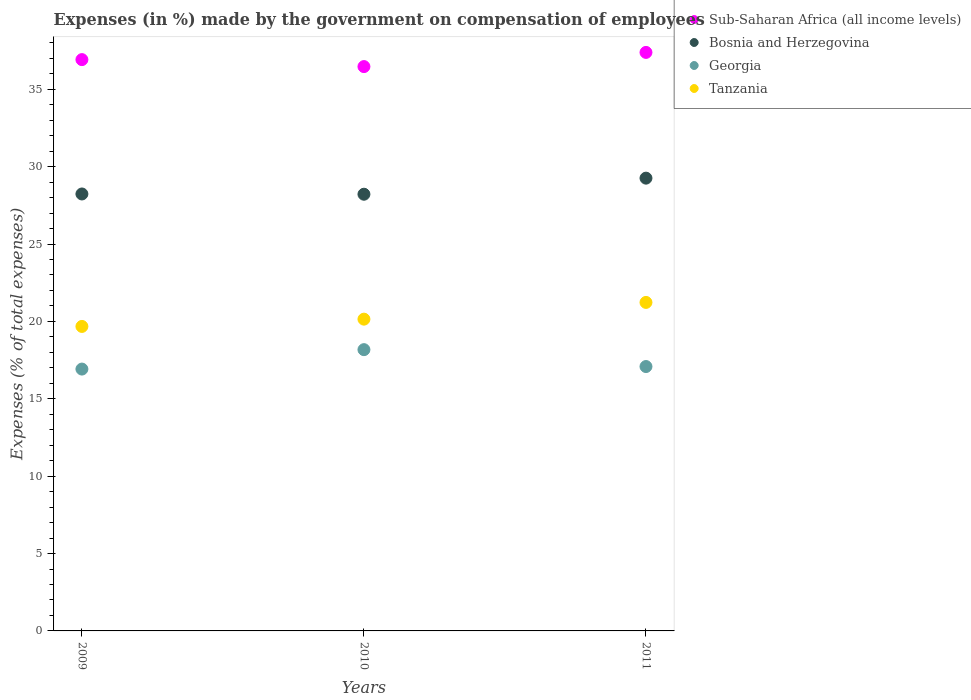How many different coloured dotlines are there?
Provide a short and direct response. 4. Is the number of dotlines equal to the number of legend labels?
Give a very brief answer. Yes. What is the percentage of expenses made by the government on compensation of employees in Sub-Saharan Africa (all income levels) in 2010?
Ensure brevity in your answer.  36.46. Across all years, what is the maximum percentage of expenses made by the government on compensation of employees in Georgia?
Your response must be concise. 18.17. Across all years, what is the minimum percentage of expenses made by the government on compensation of employees in Tanzania?
Your answer should be compact. 19.67. In which year was the percentage of expenses made by the government on compensation of employees in Sub-Saharan Africa (all income levels) maximum?
Your response must be concise. 2011. What is the total percentage of expenses made by the government on compensation of employees in Tanzania in the graph?
Your answer should be compact. 61.05. What is the difference between the percentage of expenses made by the government on compensation of employees in Tanzania in 2009 and that in 2010?
Ensure brevity in your answer.  -0.47. What is the difference between the percentage of expenses made by the government on compensation of employees in Sub-Saharan Africa (all income levels) in 2011 and the percentage of expenses made by the government on compensation of employees in Georgia in 2009?
Offer a very short reply. 20.46. What is the average percentage of expenses made by the government on compensation of employees in Tanzania per year?
Your answer should be very brief. 20.35. In the year 2011, what is the difference between the percentage of expenses made by the government on compensation of employees in Georgia and percentage of expenses made by the government on compensation of employees in Bosnia and Herzegovina?
Offer a terse response. -12.17. What is the ratio of the percentage of expenses made by the government on compensation of employees in Tanzania in 2009 to that in 2011?
Your answer should be very brief. 0.93. Is the percentage of expenses made by the government on compensation of employees in Bosnia and Herzegovina in 2009 less than that in 2011?
Offer a very short reply. Yes. Is the difference between the percentage of expenses made by the government on compensation of employees in Georgia in 2009 and 2010 greater than the difference between the percentage of expenses made by the government on compensation of employees in Bosnia and Herzegovina in 2009 and 2010?
Offer a very short reply. No. What is the difference between the highest and the second highest percentage of expenses made by the government on compensation of employees in Georgia?
Offer a terse response. 1.09. What is the difference between the highest and the lowest percentage of expenses made by the government on compensation of employees in Sub-Saharan Africa (all income levels)?
Ensure brevity in your answer.  0.92. Is it the case that in every year, the sum of the percentage of expenses made by the government on compensation of employees in Sub-Saharan Africa (all income levels) and percentage of expenses made by the government on compensation of employees in Bosnia and Herzegovina  is greater than the sum of percentage of expenses made by the government on compensation of employees in Georgia and percentage of expenses made by the government on compensation of employees in Tanzania?
Offer a very short reply. Yes. How many years are there in the graph?
Offer a terse response. 3. What is the difference between two consecutive major ticks on the Y-axis?
Give a very brief answer. 5. Are the values on the major ticks of Y-axis written in scientific E-notation?
Offer a very short reply. No. Does the graph contain any zero values?
Provide a succinct answer. No. What is the title of the graph?
Keep it short and to the point. Expenses (in %) made by the government on compensation of employees. Does "Poland" appear as one of the legend labels in the graph?
Provide a short and direct response. No. What is the label or title of the X-axis?
Your response must be concise. Years. What is the label or title of the Y-axis?
Offer a terse response. Expenses (% of total expenses). What is the Expenses (% of total expenses) in Sub-Saharan Africa (all income levels) in 2009?
Your response must be concise. 36.91. What is the Expenses (% of total expenses) of Bosnia and Herzegovina in 2009?
Your answer should be very brief. 28.23. What is the Expenses (% of total expenses) in Georgia in 2009?
Make the answer very short. 16.92. What is the Expenses (% of total expenses) in Tanzania in 2009?
Offer a very short reply. 19.67. What is the Expenses (% of total expenses) in Sub-Saharan Africa (all income levels) in 2010?
Provide a short and direct response. 36.46. What is the Expenses (% of total expenses) in Bosnia and Herzegovina in 2010?
Provide a short and direct response. 28.22. What is the Expenses (% of total expenses) in Georgia in 2010?
Your answer should be compact. 18.17. What is the Expenses (% of total expenses) of Tanzania in 2010?
Offer a terse response. 20.14. What is the Expenses (% of total expenses) in Sub-Saharan Africa (all income levels) in 2011?
Ensure brevity in your answer.  37.38. What is the Expenses (% of total expenses) of Bosnia and Herzegovina in 2011?
Ensure brevity in your answer.  29.26. What is the Expenses (% of total expenses) in Georgia in 2011?
Make the answer very short. 17.08. What is the Expenses (% of total expenses) in Tanzania in 2011?
Your response must be concise. 21.23. Across all years, what is the maximum Expenses (% of total expenses) of Sub-Saharan Africa (all income levels)?
Offer a terse response. 37.38. Across all years, what is the maximum Expenses (% of total expenses) in Bosnia and Herzegovina?
Offer a very short reply. 29.26. Across all years, what is the maximum Expenses (% of total expenses) in Georgia?
Your answer should be very brief. 18.17. Across all years, what is the maximum Expenses (% of total expenses) of Tanzania?
Make the answer very short. 21.23. Across all years, what is the minimum Expenses (% of total expenses) in Sub-Saharan Africa (all income levels)?
Keep it short and to the point. 36.46. Across all years, what is the minimum Expenses (% of total expenses) of Bosnia and Herzegovina?
Make the answer very short. 28.22. Across all years, what is the minimum Expenses (% of total expenses) of Georgia?
Offer a terse response. 16.92. Across all years, what is the minimum Expenses (% of total expenses) in Tanzania?
Your answer should be very brief. 19.67. What is the total Expenses (% of total expenses) in Sub-Saharan Africa (all income levels) in the graph?
Your response must be concise. 110.76. What is the total Expenses (% of total expenses) of Bosnia and Herzegovina in the graph?
Offer a very short reply. 85.71. What is the total Expenses (% of total expenses) of Georgia in the graph?
Offer a terse response. 52.18. What is the total Expenses (% of total expenses) in Tanzania in the graph?
Your answer should be compact. 61.05. What is the difference between the Expenses (% of total expenses) in Sub-Saharan Africa (all income levels) in 2009 and that in 2010?
Give a very brief answer. 0.45. What is the difference between the Expenses (% of total expenses) of Bosnia and Herzegovina in 2009 and that in 2010?
Keep it short and to the point. 0.02. What is the difference between the Expenses (% of total expenses) in Georgia in 2009 and that in 2010?
Keep it short and to the point. -1.26. What is the difference between the Expenses (% of total expenses) of Tanzania in 2009 and that in 2010?
Offer a terse response. -0.47. What is the difference between the Expenses (% of total expenses) in Sub-Saharan Africa (all income levels) in 2009 and that in 2011?
Provide a succinct answer. -0.47. What is the difference between the Expenses (% of total expenses) in Bosnia and Herzegovina in 2009 and that in 2011?
Provide a succinct answer. -1.02. What is the difference between the Expenses (% of total expenses) in Georgia in 2009 and that in 2011?
Make the answer very short. -0.16. What is the difference between the Expenses (% of total expenses) in Tanzania in 2009 and that in 2011?
Your response must be concise. -1.55. What is the difference between the Expenses (% of total expenses) of Sub-Saharan Africa (all income levels) in 2010 and that in 2011?
Give a very brief answer. -0.92. What is the difference between the Expenses (% of total expenses) in Bosnia and Herzegovina in 2010 and that in 2011?
Offer a very short reply. -1.04. What is the difference between the Expenses (% of total expenses) of Georgia in 2010 and that in 2011?
Offer a very short reply. 1.09. What is the difference between the Expenses (% of total expenses) of Tanzania in 2010 and that in 2011?
Your answer should be very brief. -1.08. What is the difference between the Expenses (% of total expenses) of Sub-Saharan Africa (all income levels) in 2009 and the Expenses (% of total expenses) of Bosnia and Herzegovina in 2010?
Your response must be concise. 8.7. What is the difference between the Expenses (% of total expenses) in Sub-Saharan Africa (all income levels) in 2009 and the Expenses (% of total expenses) in Georgia in 2010?
Offer a very short reply. 18.74. What is the difference between the Expenses (% of total expenses) of Sub-Saharan Africa (all income levels) in 2009 and the Expenses (% of total expenses) of Tanzania in 2010?
Your response must be concise. 16.77. What is the difference between the Expenses (% of total expenses) in Bosnia and Herzegovina in 2009 and the Expenses (% of total expenses) in Georgia in 2010?
Provide a short and direct response. 10.06. What is the difference between the Expenses (% of total expenses) of Bosnia and Herzegovina in 2009 and the Expenses (% of total expenses) of Tanzania in 2010?
Your answer should be very brief. 8.09. What is the difference between the Expenses (% of total expenses) in Georgia in 2009 and the Expenses (% of total expenses) in Tanzania in 2010?
Make the answer very short. -3.23. What is the difference between the Expenses (% of total expenses) in Sub-Saharan Africa (all income levels) in 2009 and the Expenses (% of total expenses) in Bosnia and Herzegovina in 2011?
Give a very brief answer. 7.66. What is the difference between the Expenses (% of total expenses) of Sub-Saharan Africa (all income levels) in 2009 and the Expenses (% of total expenses) of Georgia in 2011?
Your answer should be compact. 19.83. What is the difference between the Expenses (% of total expenses) in Sub-Saharan Africa (all income levels) in 2009 and the Expenses (% of total expenses) in Tanzania in 2011?
Your response must be concise. 15.69. What is the difference between the Expenses (% of total expenses) in Bosnia and Herzegovina in 2009 and the Expenses (% of total expenses) in Georgia in 2011?
Provide a short and direct response. 11.15. What is the difference between the Expenses (% of total expenses) of Bosnia and Herzegovina in 2009 and the Expenses (% of total expenses) of Tanzania in 2011?
Offer a very short reply. 7.01. What is the difference between the Expenses (% of total expenses) of Georgia in 2009 and the Expenses (% of total expenses) of Tanzania in 2011?
Give a very brief answer. -4.31. What is the difference between the Expenses (% of total expenses) in Sub-Saharan Africa (all income levels) in 2010 and the Expenses (% of total expenses) in Bosnia and Herzegovina in 2011?
Offer a terse response. 7.21. What is the difference between the Expenses (% of total expenses) in Sub-Saharan Africa (all income levels) in 2010 and the Expenses (% of total expenses) in Georgia in 2011?
Provide a succinct answer. 19.38. What is the difference between the Expenses (% of total expenses) of Sub-Saharan Africa (all income levels) in 2010 and the Expenses (% of total expenses) of Tanzania in 2011?
Make the answer very short. 15.24. What is the difference between the Expenses (% of total expenses) in Bosnia and Herzegovina in 2010 and the Expenses (% of total expenses) in Georgia in 2011?
Make the answer very short. 11.13. What is the difference between the Expenses (% of total expenses) of Bosnia and Herzegovina in 2010 and the Expenses (% of total expenses) of Tanzania in 2011?
Ensure brevity in your answer.  6.99. What is the difference between the Expenses (% of total expenses) in Georgia in 2010 and the Expenses (% of total expenses) in Tanzania in 2011?
Give a very brief answer. -3.05. What is the average Expenses (% of total expenses) in Sub-Saharan Africa (all income levels) per year?
Make the answer very short. 36.92. What is the average Expenses (% of total expenses) in Bosnia and Herzegovina per year?
Offer a terse response. 28.57. What is the average Expenses (% of total expenses) of Georgia per year?
Offer a terse response. 17.39. What is the average Expenses (% of total expenses) of Tanzania per year?
Your answer should be very brief. 20.35. In the year 2009, what is the difference between the Expenses (% of total expenses) of Sub-Saharan Africa (all income levels) and Expenses (% of total expenses) of Bosnia and Herzegovina?
Your answer should be very brief. 8.68. In the year 2009, what is the difference between the Expenses (% of total expenses) of Sub-Saharan Africa (all income levels) and Expenses (% of total expenses) of Georgia?
Your answer should be very brief. 20. In the year 2009, what is the difference between the Expenses (% of total expenses) in Sub-Saharan Africa (all income levels) and Expenses (% of total expenses) in Tanzania?
Your answer should be very brief. 17.24. In the year 2009, what is the difference between the Expenses (% of total expenses) in Bosnia and Herzegovina and Expenses (% of total expenses) in Georgia?
Provide a short and direct response. 11.31. In the year 2009, what is the difference between the Expenses (% of total expenses) in Bosnia and Herzegovina and Expenses (% of total expenses) in Tanzania?
Give a very brief answer. 8.56. In the year 2009, what is the difference between the Expenses (% of total expenses) in Georgia and Expenses (% of total expenses) in Tanzania?
Make the answer very short. -2.76. In the year 2010, what is the difference between the Expenses (% of total expenses) of Sub-Saharan Africa (all income levels) and Expenses (% of total expenses) of Bosnia and Herzegovina?
Keep it short and to the point. 8.25. In the year 2010, what is the difference between the Expenses (% of total expenses) of Sub-Saharan Africa (all income levels) and Expenses (% of total expenses) of Georgia?
Ensure brevity in your answer.  18.29. In the year 2010, what is the difference between the Expenses (% of total expenses) in Sub-Saharan Africa (all income levels) and Expenses (% of total expenses) in Tanzania?
Your response must be concise. 16.32. In the year 2010, what is the difference between the Expenses (% of total expenses) of Bosnia and Herzegovina and Expenses (% of total expenses) of Georgia?
Your answer should be compact. 10.04. In the year 2010, what is the difference between the Expenses (% of total expenses) in Bosnia and Herzegovina and Expenses (% of total expenses) in Tanzania?
Give a very brief answer. 8.07. In the year 2010, what is the difference between the Expenses (% of total expenses) in Georgia and Expenses (% of total expenses) in Tanzania?
Provide a short and direct response. -1.97. In the year 2011, what is the difference between the Expenses (% of total expenses) in Sub-Saharan Africa (all income levels) and Expenses (% of total expenses) in Bosnia and Herzegovina?
Give a very brief answer. 8.12. In the year 2011, what is the difference between the Expenses (% of total expenses) of Sub-Saharan Africa (all income levels) and Expenses (% of total expenses) of Georgia?
Provide a succinct answer. 20.3. In the year 2011, what is the difference between the Expenses (% of total expenses) in Sub-Saharan Africa (all income levels) and Expenses (% of total expenses) in Tanzania?
Offer a very short reply. 16.15. In the year 2011, what is the difference between the Expenses (% of total expenses) of Bosnia and Herzegovina and Expenses (% of total expenses) of Georgia?
Provide a succinct answer. 12.17. In the year 2011, what is the difference between the Expenses (% of total expenses) of Bosnia and Herzegovina and Expenses (% of total expenses) of Tanzania?
Provide a succinct answer. 8.03. In the year 2011, what is the difference between the Expenses (% of total expenses) of Georgia and Expenses (% of total expenses) of Tanzania?
Offer a very short reply. -4.14. What is the ratio of the Expenses (% of total expenses) in Sub-Saharan Africa (all income levels) in 2009 to that in 2010?
Provide a short and direct response. 1.01. What is the ratio of the Expenses (% of total expenses) in Bosnia and Herzegovina in 2009 to that in 2010?
Provide a short and direct response. 1. What is the ratio of the Expenses (% of total expenses) in Georgia in 2009 to that in 2010?
Provide a succinct answer. 0.93. What is the ratio of the Expenses (% of total expenses) in Tanzania in 2009 to that in 2010?
Provide a succinct answer. 0.98. What is the ratio of the Expenses (% of total expenses) of Sub-Saharan Africa (all income levels) in 2009 to that in 2011?
Your answer should be very brief. 0.99. What is the ratio of the Expenses (% of total expenses) in Bosnia and Herzegovina in 2009 to that in 2011?
Keep it short and to the point. 0.97. What is the ratio of the Expenses (% of total expenses) in Tanzania in 2009 to that in 2011?
Your answer should be compact. 0.93. What is the ratio of the Expenses (% of total expenses) of Sub-Saharan Africa (all income levels) in 2010 to that in 2011?
Offer a very short reply. 0.98. What is the ratio of the Expenses (% of total expenses) of Bosnia and Herzegovina in 2010 to that in 2011?
Provide a succinct answer. 0.96. What is the ratio of the Expenses (% of total expenses) of Georgia in 2010 to that in 2011?
Provide a short and direct response. 1.06. What is the ratio of the Expenses (% of total expenses) of Tanzania in 2010 to that in 2011?
Provide a succinct answer. 0.95. What is the difference between the highest and the second highest Expenses (% of total expenses) in Sub-Saharan Africa (all income levels)?
Ensure brevity in your answer.  0.47. What is the difference between the highest and the second highest Expenses (% of total expenses) of Bosnia and Herzegovina?
Your response must be concise. 1.02. What is the difference between the highest and the second highest Expenses (% of total expenses) of Georgia?
Offer a very short reply. 1.09. What is the difference between the highest and the second highest Expenses (% of total expenses) of Tanzania?
Make the answer very short. 1.08. What is the difference between the highest and the lowest Expenses (% of total expenses) of Sub-Saharan Africa (all income levels)?
Make the answer very short. 0.92. What is the difference between the highest and the lowest Expenses (% of total expenses) in Bosnia and Herzegovina?
Your answer should be very brief. 1.04. What is the difference between the highest and the lowest Expenses (% of total expenses) of Georgia?
Offer a very short reply. 1.26. What is the difference between the highest and the lowest Expenses (% of total expenses) of Tanzania?
Offer a very short reply. 1.55. 